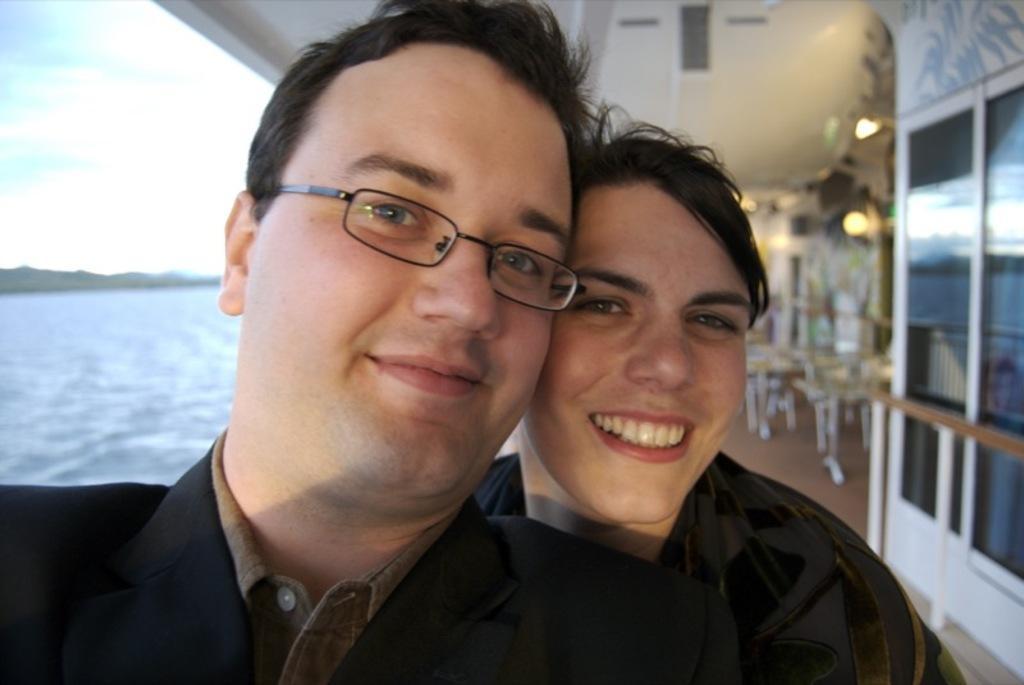Describe this image in one or two sentences. In this image we can see two persons. One person is wearing specs. On the right side there are glass walls. In the background it is blur. And we can see lights. On the left side there is water and sky. 